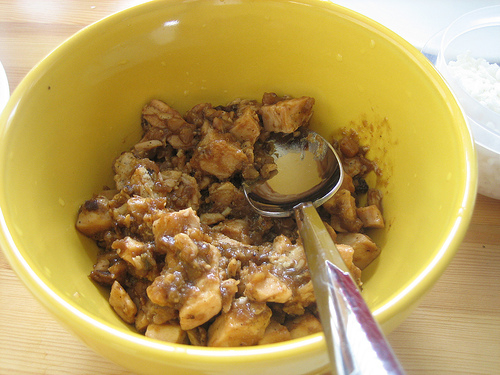<image>
Is there a spoon in front of the bowl? Yes. The spoon is positioned in front of the bowl, appearing closer to the camera viewpoint. 